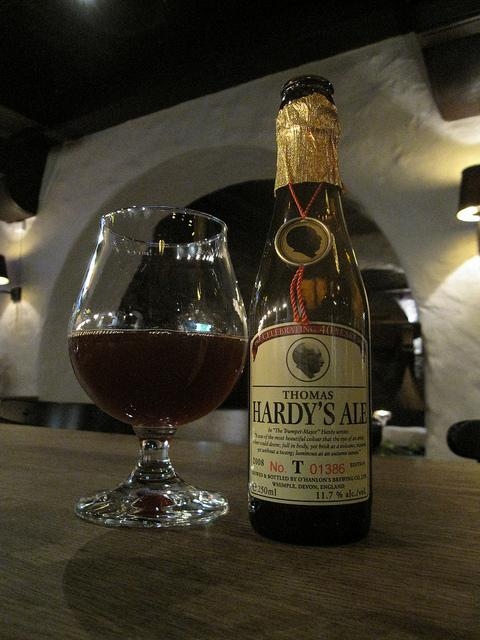What celebrity has a similar name to the name on the bottle? tom hardy 